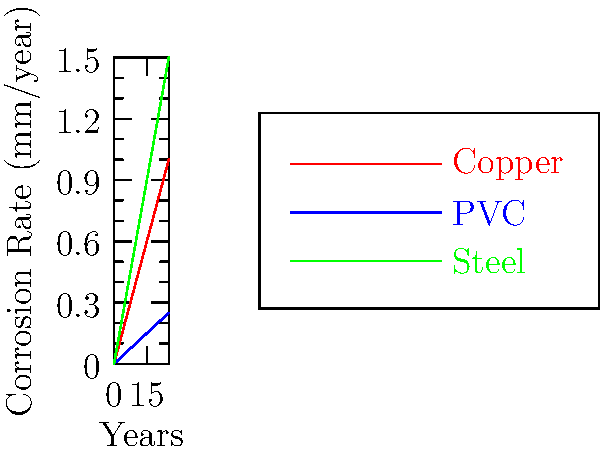Based on the corrosion rates shown in the graph for copper, PVC, and steel pipes, which material would you recommend for a homeowner looking to maximize the lifespan of their plumbing system in a highly corrosive environment? Assume that pipe failure occurs when the corrosion depth reaches 5mm, and explain your reasoning using the data provided. To determine the best material for maximizing the lifespan of the plumbing system, we need to calculate the time it takes for each material to reach the failure point (5mm corrosion depth).

Step 1: Calculate the corrosion rate for each material (slope of the line).
Copper: (1.0 - 0) / (25 - 0) = 0.04 mm/year
PVC: (0.25 - 0) / (25 - 0) = 0.01 mm/year
Steel: (1.5 - 0) / (25 - 0) = 0.06 mm/year

Step 2: Calculate the time to reach 5mm corrosion depth for each material.
Copper: 5 mm / 0.04 mm/year = 125 years
PVC: 5 mm / 0.01 mm/year = 500 years
Steel: 5 mm / 0.06 mm/year = 83.33 years

Step 3: Compare the lifespans.
PVC has the longest lifespan at 500 years, followed by copper at 125 years, and steel at 83.33 years.

Step 4: Consider the highly corrosive environment.
In a highly corrosive environment, the actual corrosion rates may be higher than shown in the graph. However, PVC is known for its excellent resistance to corrosion, which makes it even more suitable for such conditions.
Answer: PVC pipes 